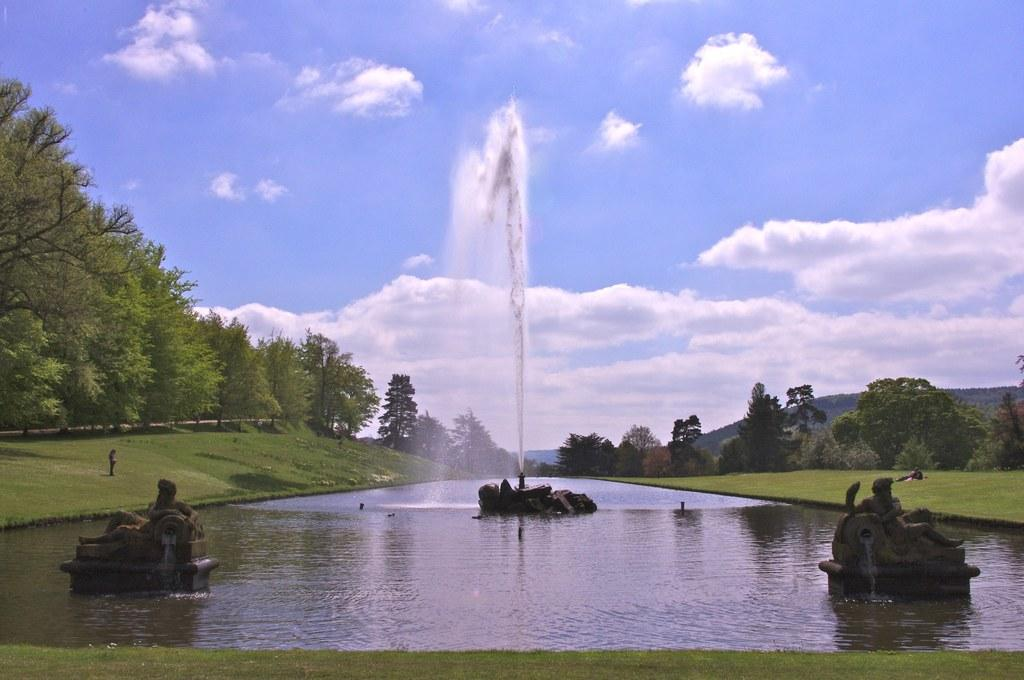What is the main feature in the picture? There is a water fountain in the picture. What is located within the water fountain? There are statues in the water. What type of natural environment is visible in the background of the picture? There is grass, trees, and the sky visible in the background of the picture. What else can be seen in the background of the picture? There are other objects in the background of the picture. What type of scientific experiment is being conducted with the bike in the picture? There is no bike present in the picture, and therefore no scientific experiment involving a bike can be observed. 